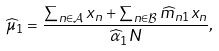Convert formula to latex. <formula><loc_0><loc_0><loc_500><loc_500>\widehat { \mu } _ { 1 } = \frac { \sum _ { n \in { \mathcal { A } } } x _ { n } + \sum _ { n \in { \mathcal { B } } } \widehat { m } _ { n 1 } x _ { n } } { \widehat { \alpha } _ { 1 } N } ,</formula> 